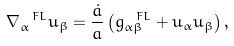Convert formula to latex. <formula><loc_0><loc_0><loc_500><loc_500>\nabla ^ { \ F L } _ { \alpha } u _ { \beta } = \frac { \dot { a } } { a } \left ( g ^ { \ F L } _ { \alpha \beta } + u _ { \alpha } u _ { \beta } \right ) ,</formula> 